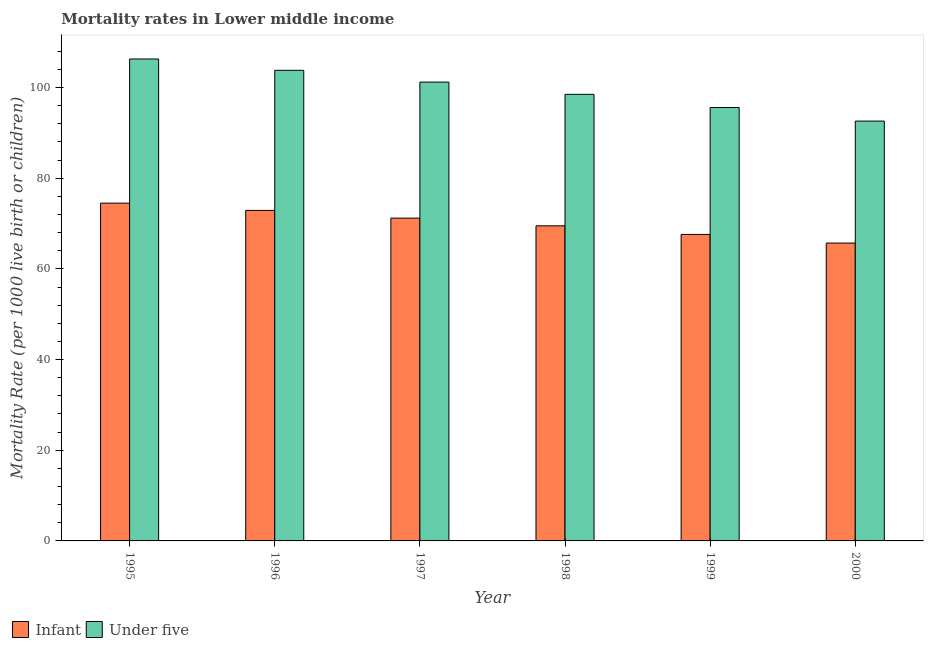Are the number of bars per tick equal to the number of legend labels?
Provide a succinct answer. Yes. Are the number of bars on each tick of the X-axis equal?
Your answer should be very brief. Yes. How many bars are there on the 2nd tick from the right?
Give a very brief answer. 2. In how many cases, is the number of bars for a given year not equal to the number of legend labels?
Your response must be concise. 0. What is the under-5 mortality rate in 2000?
Provide a succinct answer. 92.6. Across all years, what is the maximum infant mortality rate?
Offer a very short reply. 74.5. Across all years, what is the minimum infant mortality rate?
Your response must be concise. 65.7. In which year was the under-5 mortality rate minimum?
Provide a succinct answer. 2000. What is the total under-5 mortality rate in the graph?
Provide a succinct answer. 598. What is the difference between the under-5 mortality rate in 1995 and that in 1997?
Provide a succinct answer. 5.1. What is the difference between the under-5 mortality rate in 1996 and the infant mortality rate in 1999?
Give a very brief answer. 8.2. What is the average under-5 mortality rate per year?
Your response must be concise. 99.67. What is the ratio of the under-5 mortality rate in 1995 to that in 1998?
Your response must be concise. 1.08. Is the difference between the under-5 mortality rate in 1999 and 2000 greater than the difference between the infant mortality rate in 1999 and 2000?
Give a very brief answer. No. What is the difference between the highest and the lowest under-5 mortality rate?
Provide a succinct answer. 13.7. What does the 1st bar from the left in 1997 represents?
Give a very brief answer. Infant. What does the 2nd bar from the right in 1997 represents?
Provide a short and direct response. Infant. How many years are there in the graph?
Offer a terse response. 6. How are the legend labels stacked?
Provide a succinct answer. Horizontal. What is the title of the graph?
Give a very brief answer. Mortality rates in Lower middle income. What is the label or title of the X-axis?
Keep it short and to the point. Year. What is the label or title of the Y-axis?
Your answer should be very brief. Mortality Rate (per 1000 live birth or children). What is the Mortality Rate (per 1000 live birth or children) in Infant in 1995?
Make the answer very short. 74.5. What is the Mortality Rate (per 1000 live birth or children) of Under five in 1995?
Make the answer very short. 106.3. What is the Mortality Rate (per 1000 live birth or children) of Infant in 1996?
Your answer should be compact. 72.9. What is the Mortality Rate (per 1000 live birth or children) of Under five in 1996?
Make the answer very short. 103.8. What is the Mortality Rate (per 1000 live birth or children) of Infant in 1997?
Ensure brevity in your answer.  71.2. What is the Mortality Rate (per 1000 live birth or children) of Under five in 1997?
Provide a short and direct response. 101.2. What is the Mortality Rate (per 1000 live birth or children) in Infant in 1998?
Ensure brevity in your answer.  69.5. What is the Mortality Rate (per 1000 live birth or children) in Under five in 1998?
Keep it short and to the point. 98.5. What is the Mortality Rate (per 1000 live birth or children) of Infant in 1999?
Provide a succinct answer. 67.6. What is the Mortality Rate (per 1000 live birth or children) of Under five in 1999?
Offer a terse response. 95.6. What is the Mortality Rate (per 1000 live birth or children) of Infant in 2000?
Your answer should be very brief. 65.7. What is the Mortality Rate (per 1000 live birth or children) in Under five in 2000?
Ensure brevity in your answer.  92.6. Across all years, what is the maximum Mortality Rate (per 1000 live birth or children) of Infant?
Provide a short and direct response. 74.5. Across all years, what is the maximum Mortality Rate (per 1000 live birth or children) in Under five?
Provide a short and direct response. 106.3. Across all years, what is the minimum Mortality Rate (per 1000 live birth or children) of Infant?
Offer a very short reply. 65.7. Across all years, what is the minimum Mortality Rate (per 1000 live birth or children) in Under five?
Ensure brevity in your answer.  92.6. What is the total Mortality Rate (per 1000 live birth or children) in Infant in the graph?
Ensure brevity in your answer.  421.4. What is the total Mortality Rate (per 1000 live birth or children) in Under five in the graph?
Provide a succinct answer. 598. What is the difference between the Mortality Rate (per 1000 live birth or children) in Under five in 1995 and that in 1996?
Offer a terse response. 2.5. What is the difference between the Mortality Rate (per 1000 live birth or children) of Under five in 1995 and that in 1997?
Your answer should be very brief. 5.1. What is the difference between the Mortality Rate (per 1000 live birth or children) of Infant in 1995 and that in 1998?
Your answer should be compact. 5. What is the difference between the Mortality Rate (per 1000 live birth or children) in Under five in 1995 and that in 1998?
Provide a succinct answer. 7.8. What is the difference between the Mortality Rate (per 1000 live birth or children) in Under five in 1995 and that in 1999?
Provide a short and direct response. 10.7. What is the difference between the Mortality Rate (per 1000 live birth or children) in Infant in 1995 and that in 2000?
Offer a terse response. 8.8. What is the difference between the Mortality Rate (per 1000 live birth or children) in Infant in 1996 and that in 1997?
Keep it short and to the point. 1.7. What is the difference between the Mortality Rate (per 1000 live birth or children) of Under five in 1996 and that in 1998?
Give a very brief answer. 5.3. What is the difference between the Mortality Rate (per 1000 live birth or children) of Infant in 1996 and that in 1999?
Offer a terse response. 5.3. What is the difference between the Mortality Rate (per 1000 live birth or children) of Under five in 1996 and that in 1999?
Ensure brevity in your answer.  8.2. What is the difference between the Mortality Rate (per 1000 live birth or children) of Infant in 1996 and that in 2000?
Offer a terse response. 7.2. What is the difference between the Mortality Rate (per 1000 live birth or children) of Under five in 1996 and that in 2000?
Offer a very short reply. 11.2. What is the difference between the Mortality Rate (per 1000 live birth or children) in Infant in 1997 and that in 1998?
Offer a terse response. 1.7. What is the difference between the Mortality Rate (per 1000 live birth or children) of Infant in 1997 and that in 1999?
Your answer should be compact. 3.6. What is the difference between the Mortality Rate (per 1000 live birth or children) in Under five in 1997 and that in 2000?
Keep it short and to the point. 8.6. What is the difference between the Mortality Rate (per 1000 live birth or children) in Under five in 1998 and that in 2000?
Provide a short and direct response. 5.9. What is the difference between the Mortality Rate (per 1000 live birth or children) of Under five in 1999 and that in 2000?
Your answer should be compact. 3. What is the difference between the Mortality Rate (per 1000 live birth or children) of Infant in 1995 and the Mortality Rate (per 1000 live birth or children) of Under five in 1996?
Offer a very short reply. -29.3. What is the difference between the Mortality Rate (per 1000 live birth or children) of Infant in 1995 and the Mortality Rate (per 1000 live birth or children) of Under five in 1997?
Make the answer very short. -26.7. What is the difference between the Mortality Rate (per 1000 live birth or children) of Infant in 1995 and the Mortality Rate (per 1000 live birth or children) of Under five in 1998?
Give a very brief answer. -24. What is the difference between the Mortality Rate (per 1000 live birth or children) of Infant in 1995 and the Mortality Rate (per 1000 live birth or children) of Under five in 1999?
Provide a succinct answer. -21.1. What is the difference between the Mortality Rate (per 1000 live birth or children) of Infant in 1995 and the Mortality Rate (per 1000 live birth or children) of Under five in 2000?
Offer a terse response. -18.1. What is the difference between the Mortality Rate (per 1000 live birth or children) in Infant in 1996 and the Mortality Rate (per 1000 live birth or children) in Under five in 1997?
Keep it short and to the point. -28.3. What is the difference between the Mortality Rate (per 1000 live birth or children) of Infant in 1996 and the Mortality Rate (per 1000 live birth or children) of Under five in 1998?
Offer a terse response. -25.6. What is the difference between the Mortality Rate (per 1000 live birth or children) of Infant in 1996 and the Mortality Rate (per 1000 live birth or children) of Under five in 1999?
Your answer should be compact. -22.7. What is the difference between the Mortality Rate (per 1000 live birth or children) of Infant in 1996 and the Mortality Rate (per 1000 live birth or children) of Under five in 2000?
Provide a succinct answer. -19.7. What is the difference between the Mortality Rate (per 1000 live birth or children) of Infant in 1997 and the Mortality Rate (per 1000 live birth or children) of Under five in 1998?
Your answer should be compact. -27.3. What is the difference between the Mortality Rate (per 1000 live birth or children) in Infant in 1997 and the Mortality Rate (per 1000 live birth or children) in Under five in 1999?
Offer a very short reply. -24.4. What is the difference between the Mortality Rate (per 1000 live birth or children) of Infant in 1997 and the Mortality Rate (per 1000 live birth or children) of Under five in 2000?
Give a very brief answer. -21.4. What is the difference between the Mortality Rate (per 1000 live birth or children) of Infant in 1998 and the Mortality Rate (per 1000 live birth or children) of Under five in 1999?
Provide a succinct answer. -26.1. What is the difference between the Mortality Rate (per 1000 live birth or children) of Infant in 1998 and the Mortality Rate (per 1000 live birth or children) of Under five in 2000?
Your answer should be very brief. -23.1. What is the difference between the Mortality Rate (per 1000 live birth or children) in Infant in 1999 and the Mortality Rate (per 1000 live birth or children) in Under five in 2000?
Your answer should be very brief. -25. What is the average Mortality Rate (per 1000 live birth or children) in Infant per year?
Provide a short and direct response. 70.23. What is the average Mortality Rate (per 1000 live birth or children) of Under five per year?
Your answer should be very brief. 99.67. In the year 1995, what is the difference between the Mortality Rate (per 1000 live birth or children) in Infant and Mortality Rate (per 1000 live birth or children) in Under five?
Your response must be concise. -31.8. In the year 1996, what is the difference between the Mortality Rate (per 1000 live birth or children) of Infant and Mortality Rate (per 1000 live birth or children) of Under five?
Keep it short and to the point. -30.9. In the year 2000, what is the difference between the Mortality Rate (per 1000 live birth or children) of Infant and Mortality Rate (per 1000 live birth or children) of Under five?
Your response must be concise. -26.9. What is the ratio of the Mortality Rate (per 1000 live birth or children) in Infant in 1995 to that in 1996?
Offer a very short reply. 1.02. What is the ratio of the Mortality Rate (per 1000 live birth or children) of Under five in 1995 to that in 1996?
Give a very brief answer. 1.02. What is the ratio of the Mortality Rate (per 1000 live birth or children) of Infant in 1995 to that in 1997?
Offer a terse response. 1.05. What is the ratio of the Mortality Rate (per 1000 live birth or children) of Under five in 1995 to that in 1997?
Provide a short and direct response. 1.05. What is the ratio of the Mortality Rate (per 1000 live birth or children) in Infant in 1995 to that in 1998?
Ensure brevity in your answer.  1.07. What is the ratio of the Mortality Rate (per 1000 live birth or children) of Under five in 1995 to that in 1998?
Offer a very short reply. 1.08. What is the ratio of the Mortality Rate (per 1000 live birth or children) in Infant in 1995 to that in 1999?
Offer a terse response. 1.1. What is the ratio of the Mortality Rate (per 1000 live birth or children) in Under five in 1995 to that in 1999?
Ensure brevity in your answer.  1.11. What is the ratio of the Mortality Rate (per 1000 live birth or children) in Infant in 1995 to that in 2000?
Provide a short and direct response. 1.13. What is the ratio of the Mortality Rate (per 1000 live birth or children) in Under five in 1995 to that in 2000?
Your answer should be very brief. 1.15. What is the ratio of the Mortality Rate (per 1000 live birth or children) in Infant in 1996 to that in 1997?
Provide a short and direct response. 1.02. What is the ratio of the Mortality Rate (per 1000 live birth or children) of Under five in 1996 to that in 1997?
Your answer should be compact. 1.03. What is the ratio of the Mortality Rate (per 1000 live birth or children) of Infant in 1996 to that in 1998?
Keep it short and to the point. 1.05. What is the ratio of the Mortality Rate (per 1000 live birth or children) in Under five in 1996 to that in 1998?
Keep it short and to the point. 1.05. What is the ratio of the Mortality Rate (per 1000 live birth or children) of Infant in 1996 to that in 1999?
Offer a very short reply. 1.08. What is the ratio of the Mortality Rate (per 1000 live birth or children) in Under five in 1996 to that in 1999?
Provide a short and direct response. 1.09. What is the ratio of the Mortality Rate (per 1000 live birth or children) in Infant in 1996 to that in 2000?
Your answer should be compact. 1.11. What is the ratio of the Mortality Rate (per 1000 live birth or children) of Under five in 1996 to that in 2000?
Provide a succinct answer. 1.12. What is the ratio of the Mortality Rate (per 1000 live birth or children) in Infant in 1997 to that in 1998?
Your answer should be very brief. 1.02. What is the ratio of the Mortality Rate (per 1000 live birth or children) of Under five in 1997 to that in 1998?
Your answer should be compact. 1.03. What is the ratio of the Mortality Rate (per 1000 live birth or children) in Infant in 1997 to that in 1999?
Ensure brevity in your answer.  1.05. What is the ratio of the Mortality Rate (per 1000 live birth or children) of Under five in 1997 to that in 1999?
Ensure brevity in your answer.  1.06. What is the ratio of the Mortality Rate (per 1000 live birth or children) in Infant in 1997 to that in 2000?
Keep it short and to the point. 1.08. What is the ratio of the Mortality Rate (per 1000 live birth or children) in Under five in 1997 to that in 2000?
Provide a succinct answer. 1.09. What is the ratio of the Mortality Rate (per 1000 live birth or children) of Infant in 1998 to that in 1999?
Ensure brevity in your answer.  1.03. What is the ratio of the Mortality Rate (per 1000 live birth or children) of Under five in 1998 to that in 1999?
Provide a short and direct response. 1.03. What is the ratio of the Mortality Rate (per 1000 live birth or children) in Infant in 1998 to that in 2000?
Provide a succinct answer. 1.06. What is the ratio of the Mortality Rate (per 1000 live birth or children) of Under five in 1998 to that in 2000?
Offer a terse response. 1.06. What is the ratio of the Mortality Rate (per 1000 live birth or children) in Infant in 1999 to that in 2000?
Provide a succinct answer. 1.03. What is the ratio of the Mortality Rate (per 1000 live birth or children) of Under five in 1999 to that in 2000?
Your response must be concise. 1.03. What is the difference between the highest and the second highest Mortality Rate (per 1000 live birth or children) in Under five?
Provide a short and direct response. 2.5. What is the difference between the highest and the lowest Mortality Rate (per 1000 live birth or children) of Under five?
Provide a short and direct response. 13.7. 